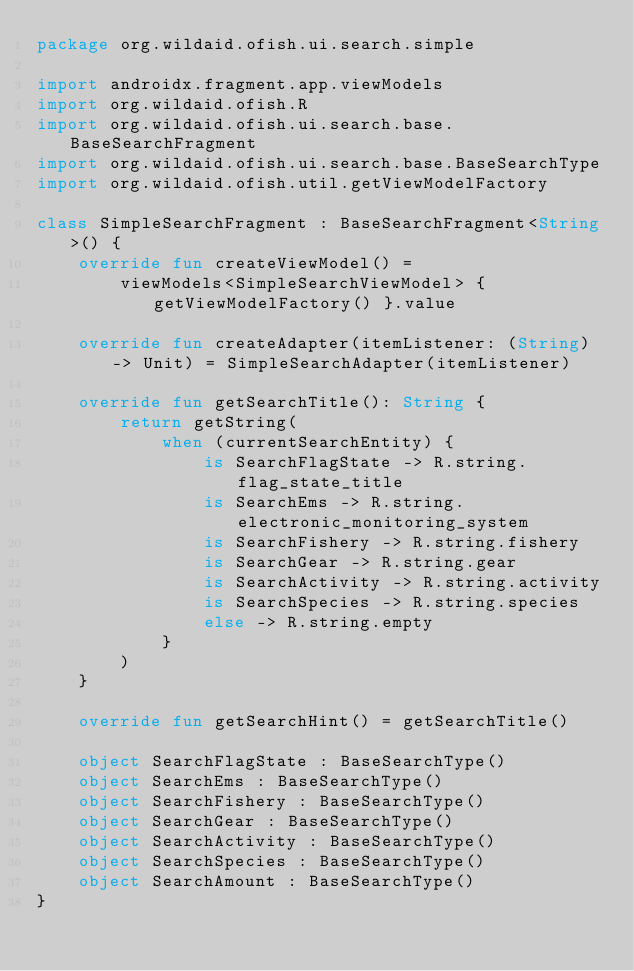Convert code to text. <code><loc_0><loc_0><loc_500><loc_500><_Kotlin_>package org.wildaid.ofish.ui.search.simple

import androidx.fragment.app.viewModels
import org.wildaid.ofish.R
import org.wildaid.ofish.ui.search.base.BaseSearchFragment
import org.wildaid.ofish.ui.search.base.BaseSearchType
import org.wildaid.ofish.util.getViewModelFactory

class SimpleSearchFragment : BaseSearchFragment<String>() {
    override fun createViewModel() =
        viewModels<SimpleSearchViewModel> { getViewModelFactory() }.value

    override fun createAdapter(itemListener: (String) -> Unit) = SimpleSearchAdapter(itemListener)

    override fun getSearchTitle(): String {
        return getString(
            when (currentSearchEntity) {
                is SearchFlagState -> R.string.flag_state_title
                is SearchEms -> R.string.electronic_monitoring_system
                is SearchFishery -> R.string.fishery
                is SearchGear -> R.string.gear
                is SearchActivity -> R.string.activity
                is SearchSpecies -> R.string.species
                else -> R.string.empty
            }
        )
    }

    override fun getSearchHint() = getSearchTitle()

    object SearchFlagState : BaseSearchType()
    object SearchEms : BaseSearchType()
    object SearchFishery : BaseSearchType()
    object SearchGear : BaseSearchType()
    object SearchActivity : BaseSearchType()
    object SearchSpecies : BaseSearchType()
    object SearchAmount : BaseSearchType()
}</code> 